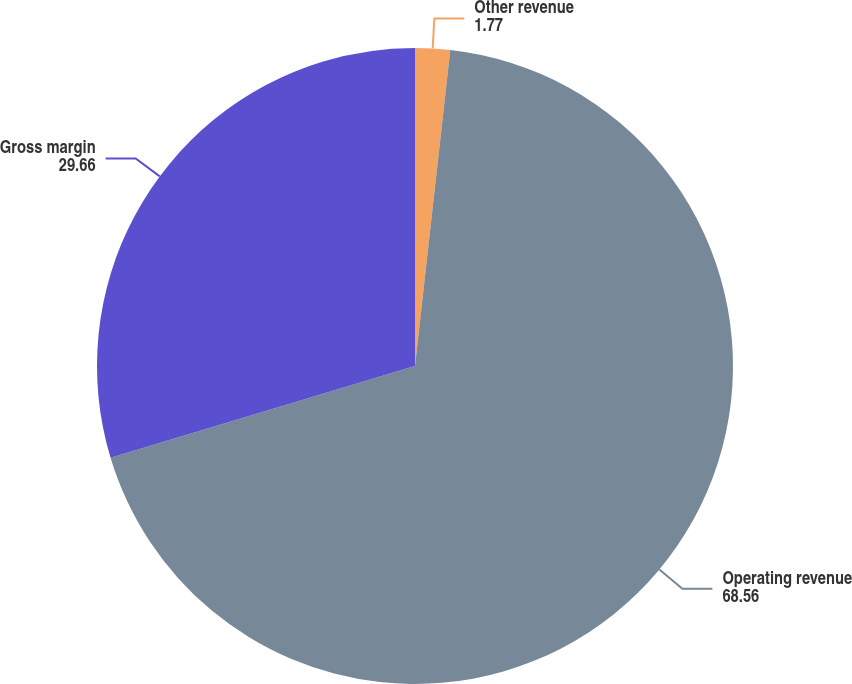Convert chart to OTSL. <chart><loc_0><loc_0><loc_500><loc_500><pie_chart><fcel>Other revenue<fcel>Operating revenue<fcel>Gross margin<nl><fcel>1.77%<fcel>68.56%<fcel>29.66%<nl></chart> 